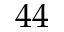Convert formula to latex. <formula><loc_0><loc_0><loc_500><loc_500>4 4</formula> 